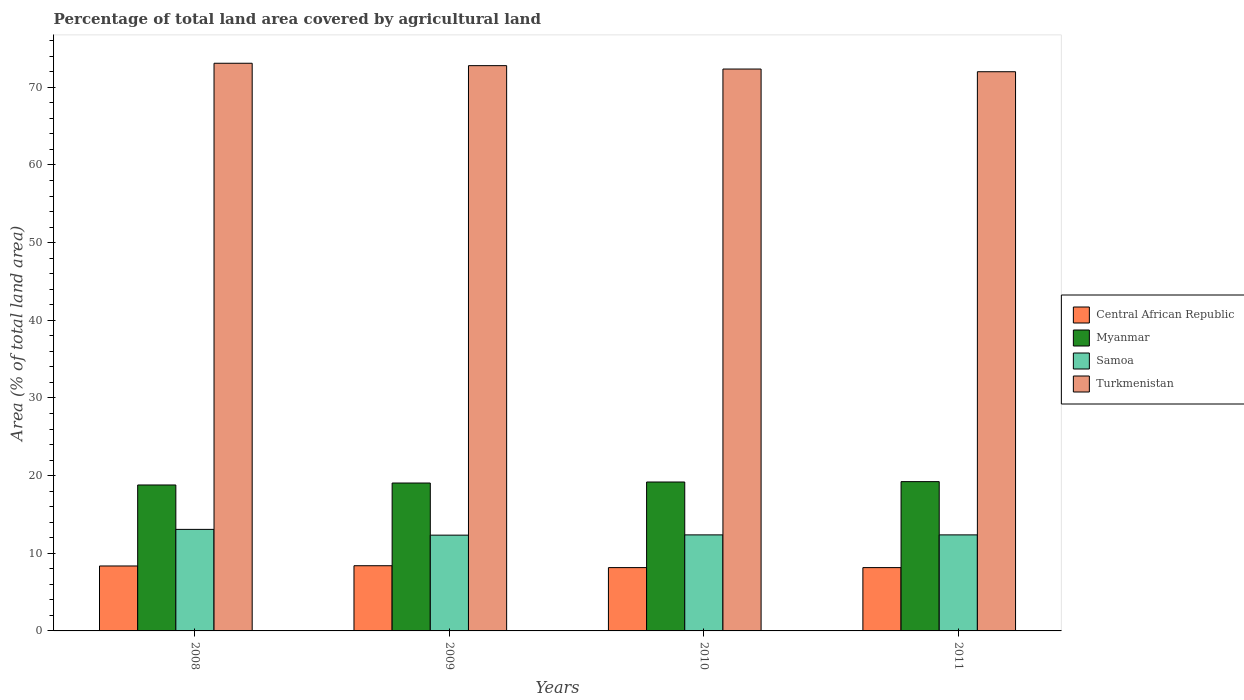How many different coloured bars are there?
Your response must be concise. 4. Are the number of bars per tick equal to the number of legend labels?
Give a very brief answer. Yes. Are the number of bars on each tick of the X-axis equal?
Provide a succinct answer. Yes. How many bars are there on the 4th tick from the left?
Your answer should be very brief. 4. How many bars are there on the 1st tick from the right?
Offer a very short reply. 4. In how many cases, is the number of bars for a given year not equal to the number of legend labels?
Provide a succinct answer. 0. What is the percentage of agricultural land in Central African Republic in 2011?
Ensure brevity in your answer.  8.15. Across all years, what is the maximum percentage of agricultural land in Samoa?
Make the answer very short. 13.07. Across all years, what is the minimum percentage of agricultural land in Samoa?
Your response must be concise. 12.33. In which year was the percentage of agricultural land in Turkmenistan maximum?
Your response must be concise. 2008. In which year was the percentage of agricultural land in Myanmar minimum?
Make the answer very short. 2008. What is the total percentage of agricultural land in Myanmar in the graph?
Make the answer very short. 76.23. What is the difference between the percentage of agricultural land in Turkmenistan in 2011 and the percentage of agricultural land in Myanmar in 2009?
Provide a short and direct response. 52.96. What is the average percentage of agricultural land in Samoa per year?
Offer a terse response. 12.54. In the year 2010, what is the difference between the percentage of agricultural land in Turkmenistan and percentage of agricultural land in Myanmar?
Your answer should be very brief. 53.18. In how many years, is the percentage of agricultural land in Central African Republic greater than 34 %?
Make the answer very short. 0. What is the ratio of the percentage of agricultural land in Turkmenistan in 2009 to that in 2011?
Keep it short and to the point. 1.01. Is the difference between the percentage of agricultural land in Turkmenistan in 2008 and 2009 greater than the difference between the percentage of agricultural land in Myanmar in 2008 and 2009?
Your response must be concise. Yes. What is the difference between the highest and the second highest percentage of agricultural land in Central African Republic?
Your response must be concise. 0.03. What is the difference between the highest and the lowest percentage of agricultural land in Myanmar?
Offer a terse response. 0.43. In how many years, is the percentage of agricultural land in Turkmenistan greater than the average percentage of agricultural land in Turkmenistan taken over all years?
Ensure brevity in your answer.  2. Is the sum of the percentage of agricultural land in Myanmar in 2008 and 2010 greater than the maximum percentage of agricultural land in Turkmenistan across all years?
Make the answer very short. No. What does the 4th bar from the left in 2009 represents?
Offer a terse response. Turkmenistan. What does the 2nd bar from the right in 2009 represents?
Give a very brief answer. Samoa. Is it the case that in every year, the sum of the percentage of agricultural land in Central African Republic and percentage of agricultural land in Samoa is greater than the percentage of agricultural land in Myanmar?
Give a very brief answer. Yes. How many bars are there?
Offer a very short reply. 16. How many years are there in the graph?
Give a very brief answer. 4. Where does the legend appear in the graph?
Your response must be concise. Center right. How many legend labels are there?
Your answer should be compact. 4. What is the title of the graph?
Offer a very short reply. Percentage of total land area covered by agricultural land. What is the label or title of the Y-axis?
Give a very brief answer. Area (% of total land area). What is the Area (% of total land area) in Central African Republic in 2008?
Make the answer very short. 8.36. What is the Area (% of total land area) in Myanmar in 2008?
Keep it short and to the point. 18.79. What is the Area (% of total land area) in Samoa in 2008?
Make the answer very short. 13.07. What is the Area (% of total land area) in Turkmenistan in 2008?
Give a very brief answer. 73.1. What is the Area (% of total land area) of Central African Republic in 2009?
Your answer should be very brief. 8.4. What is the Area (% of total land area) in Myanmar in 2009?
Provide a succinct answer. 19.04. What is the Area (% of total land area) of Samoa in 2009?
Your answer should be very brief. 12.33. What is the Area (% of total land area) of Turkmenistan in 2009?
Your answer should be compact. 72.79. What is the Area (% of total land area) of Central African Republic in 2010?
Your response must be concise. 8.15. What is the Area (% of total land area) of Myanmar in 2010?
Give a very brief answer. 19.17. What is the Area (% of total land area) of Samoa in 2010?
Your answer should be compact. 12.37. What is the Area (% of total land area) of Turkmenistan in 2010?
Your answer should be compact. 72.35. What is the Area (% of total land area) of Central African Republic in 2011?
Make the answer very short. 8.15. What is the Area (% of total land area) of Myanmar in 2011?
Provide a short and direct response. 19.22. What is the Area (% of total land area) of Samoa in 2011?
Your response must be concise. 12.37. What is the Area (% of total land area) of Turkmenistan in 2011?
Your answer should be compact. 72.01. Across all years, what is the maximum Area (% of total land area) of Central African Republic?
Offer a terse response. 8.4. Across all years, what is the maximum Area (% of total land area) of Myanmar?
Your response must be concise. 19.22. Across all years, what is the maximum Area (% of total land area) in Samoa?
Provide a short and direct response. 13.07. Across all years, what is the maximum Area (% of total land area) in Turkmenistan?
Offer a very short reply. 73.1. Across all years, what is the minimum Area (% of total land area) in Central African Republic?
Make the answer very short. 8.15. Across all years, what is the minimum Area (% of total land area) of Myanmar?
Keep it short and to the point. 18.79. Across all years, what is the minimum Area (% of total land area) in Samoa?
Offer a very short reply. 12.33. Across all years, what is the minimum Area (% of total land area) in Turkmenistan?
Provide a succinct answer. 72.01. What is the total Area (% of total land area) of Central African Republic in the graph?
Keep it short and to the point. 33.07. What is the total Area (% of total land area) of Myanmar in the graph?
Ensure brevity in your answer.  76.23. What is the total Area (% of total land area) in Samoa in the graph?
Your answer should be very brief. 50.14. What is the total Area (% of total land area) of Turkmenistan in the graph?
Offer a very short reply. 290.24. What is the difference between the Area (% of total land area) in Central African Republic in 2008 and that in 2009?
Your answer should be compact. -0.03. What is the difference between the Area (% of total land area) of Myanmar in 2008 and that in 2009?
Your response must be concise. -0.25. What is the difference between the Area (% of total land area) of Samoa in 2008 and that in 2009?
Ensure brevity in your answer.  0.74. What is the difference between the Area (% of total land area) in Turkmenistan in 2008 and that in 2009?
Your answer should be very brief. 0.31. What is the difference between the Area (% of total land area) of Central African Republic in 2008 and that in 2010?
Keep it short and to the point. 0.21. What is the difference between the Area (% of total land area) in Myanmar in 2008 and that in 2010?
Offer a very short reply. -0.38. What is the difference between the Area (% of total land area) in Samoa in 2008 and that in 2010?
Offer a terse response. 0.71. What is the difference between the Area (% of total land area) of Turkmenistan in 2008 and that in 2010?
Your response must be concise. 0.74. What is the difference between the Area (% of total land area) of Central African Republic in 2008 and that in 2011?
Your response must be concise. 0.21. What is the difference between the Area (% of total land area) of Myanmar in 2008 and that in 2011?
Provide a short and direct response. -0.43. What is the difference between the Area (% of total land area) of Samoa in 2008 and that in 2011?
Your answer should be very brief. 0.71. What is the difference between the Area (% of total land area) of Turkmenistan in 2008 and that in 2011?
Your response must be concise. 1.09. What is the difference between the Area (% of total land area) in Central African Republic in 2009 and that in 2010?
Keep it short and to the point. 0.24. What is the difference between the Area (% of total land area) in Myanmar in 2009 and that in 2010?
Give a very brief answer. -0.13. What is the difference between the Area (% of total land area) in Samoa in 2009 and that in 2010?
Give a very brief answer. -0.04. What is the difference between the Area (% of total land area) in Turkmenistan in 2009 and that in 2010?
Your response must be concise. 0.44. What is the difference between the Area (% of total land area) of Central African Republic in 2009 and that in 2011?
Ensure brevity in your answer.  0.24. What is the difference between the Area (% of total land area) of Myanmar in 2009 and that in 2011?
Offer a very short reply. -0.18. What is the difference between the Area (% of total land area) of Samoa in 2009 and that in 2011?
Keep it short and to the point. -0.04. What is the difference between the Area (% of total land area) in Turkmenistan in 2009 and that in 2011?
Give a very brief answer. 0.78. What is the difference between the Area (% of total land area) in Central African Republic in 2010 and that in 2011?
Provide a short and direct response. 0. What is the difference between the Area (% of total land area) in Myanmar in 2010 and that in 2011?
Give a very brief answer. -0.05. What is the difference between the Area (% of total land area) of Turkmenistan in 2010 and that in 2011?
Your response must be concise. 0.34. What is the difference between the Area (% of total land area) of Central African Republic in 2008 and the Area (% of total land area) of Myanmar in 2009?
Make the answer very short. -10.68. What is the difference between the Area (% of total land area) of Central African Republic in 2008 and the Area (% of total land area) of Samoa in 2009?
Your response must be concise. -3.97. What is the difference between the Area (% of total land area) of Central African Republic in 2008 and the Area (% of total land area) of Turkmenistan in 2009?
Keep it short and to the point. -64.42. What is the difference between the Area (% of total land area) in Myanmar in 2008 and the Area (% of total land area) in Samoa in 2009?
Keep it short and to the point. 6.46. What is the difference between the Area (% of total land area) of Myanmar in 2008 and the Area (% of total land area) of Turkmenistan in 2009?
Offer a terse response. -54. What is the difference between the Area (% of total land area) of Samoa in 2008 and the Area (% of total land area) of Turkmenistan in 2009?
Provide a short and direct response. -59.71. What is the difference between the Area (% of total land area) of Central African Republic in 2008 and the Area (% of total land area) of Myanmar in 2010?
Offer a terse response. -10.81. What is the difference between the Area (% of total land area) in Central African Republic in 2008 and the Area (% of total land area) in Samoa in 2010?
Your answer should be very brief. -4. What is the difference between the Area (% of total land area) of Central African Republic in 2008 and the Area (% of total land area) of Turkmenistan in 2010?
Make the answer very short. -63.99. What is the difference between the Area (% of total land area) of Myanmar in 2008 and the Area (% of total land area) of Samoa in 2010?
Your answer should be compact. 6.42. What is the difference between the Area (% of total land area) of Myanmar in 2008 and the Area (% of total land area) of Turkmenistan in 2010?
Provide a succinct answer. -53.56. What is the difference between the Area (% of total land area) in Samoa in 2008 and the Area (% of total land area) in Turkmenistan in 2010?
Provide a succinct answer. -59.28. What is the difference between the Area (% of total land area) in Central African Republic in 2008 and the Area (% of total land area) in Myanmar in 2011?
Offer a very short reply. -10.86. What is the difference between the Area (% of total land area) in Central African Republic in 2008 and the Area (% of total land area) in Samoa in 2011?
Provide a short and direct response. -4. What is the difference between the Area (% of total land area) of Central African Republic in 2008 and the Area (% of total land area) of Turkmenistan in 2011?
Offer a very short reply. -63.64. What is the difference between the Area (% of total land area) of Myanmar in 2008 and the Area (% of total land area) of Samoa in 2011?
Give a very brief answer. 6.42. What is the difference between the Area (% of total land area) of Myanmar in 2008 and the Area (% of total land area) of Turkmenistan in 2011?
Make the answer very short. -53.21. What is the difference between the Area (% of total land area) of Samoa in 2008 and the Area (% of total land area) of Turkmenistan in 2011?
Offer a very short reply. -58.93. What is the difference between the Area (% of total land area) of Central African Republic in 2009 and the Area (% of total land area) of Myanmar in 2010?
Provide a succinct answer. -10.78. What is the difference between the Area (% of total land area) in Central African Republic in 2009 and the Area (% of total land area) in Samoa in 2010?
Make the answer very short. -3.97. What is the difference between the Area (% of total land area) in Central African Republic in 2009 and the Area (% of total land area) in Turkmenistan in 2010?
Ensure brevity in your answer.  -63.96. What is the difference between the Area (% of total land area) of Myanmar in 2009 and the Area (% of total land area) of Samoa in 2010?
Your response must be concise. 6.68. What is the difference between the Area (% of total land area) in Myanmar in 2009 and the Area (% of total land area) in Turkmenistan in 2010?
Offer a terse response. -53.31. What is the difference between the Area (% of total land area) of Samoa in 2009 and the Area (% of total land area) of Turkmenistan in 2010?
Make the answer very short. -60.02. What is the difference between the Area (% of total land area) in Central African Republic in 2009 and the Area (% of total land area) in Myanmar in 2011?
Your response must be concise. -10.83. What is the difference between the Area (% of total land area) in Central African Republic in 2009 and the Area (% of total land area) in Samoa in 2011?
Keep it short and to the point. -3.97. What is the difference between the Area (% of total land area) in Central African Republic in 2009 and the Area (% of total land area) in Turkmenistan in 2011?
Make the answer very short. -63.61. What is the difference between the Area (% of total land area) of Myanmar in 2009 and the Area (% of total land area) of Samoa in 2011?
Your answer should be very brief. 6.68. What is the difference between the Area (% of total land area) of Myanmar in 2009 and the Area (% of total land area) of Turkmenistan in 2011?
Provide a succinct answer. -52.96. What is the difference between the Area (% of total land area) of Samoa in 2009 and the Area (% of total land area) of Turkmenistan in 2011?
Keep it short and to the point. -59.67. What is the difference between the Area (% of total land area) in Central African Republic in 2010 and the Area (% of total land area) in Myanmar in 2011?
Make the answer very short. -11.07. What is the difference between the Area (% of total land area) in Central African Republic in 2010 and the Area (% of total land area) in Samoa in 2011?
Keep it short and to the point. -4.21. What is the difference between the Area (% of total land area) in Central African Republic in 2010 and the Area (% of total land area) in Turkmenistan in 2011?
Provide a short and direct response. -63.85. What is the difference between the Area (% of total land area) in Myanmar in 2010 and the Area (% of total land area) in Samoa in 2011?
Provide a succinct answer. 6.81. What is the difference between the Area (% of total land area) in Myanmar in 2010 and the Area (% of total land area) in Turkmenistan in 2011?
Give a very brief answer. -52.83. What is the difference between the Area (% of total land area) in Samoa in 2010 and the Area (% of total land area) in Turkmenistan in 2011?
Provide a short and direct response. -59.64. What is the average Area (% of total land area) in Central African Republic per year?
Your answer should be compact. 8.27. What is the average Area (% of total land area) of Myanmar per year?
Give a very brief answer. 19.06. What is the average Area (% of total land area) of Samoa per year?
Give a very brief answer. 12.54. What is the average Area (% of total land area) in Turkmenistan per year?
Keep it short and to the point. 72.56. In the year 2008, what is the difference between the Area (% of total land area) of Central African Republic and Area (% of total land area) of Myanmar?
Offer a very short reply. -10.43. In the year 2008, what is the difference between the Area (% of total land area) in Central African Republic and Area (% of total land area) in Samoa?
Make the answer very short. -4.71. In the year 2008, what is the difference between the Area (% of total land area) in Central African Republic and Area (% of total land area) in Turkmenistan?
Ensure brevity in your answer.  -64.73. In the year 2008, what is the difference between the Area (% of total land area) of Myanmar and Area (% of total land area) of Samoa?
Offer a very short reply. 5.72. In the year 2008, what is the difference between the Area (% of total land area) in Myanmar and Area (% of total land area) in Turkmenistan?
Ensure brevity in your answer.  -54.3. In the year 2008, what is the difference between the Area (% of total land area) in Samoa and Area (% of total land area) in Turkmenistan?
Offer a terse response. -60.02. In the year 2009, what is the difference between the Area (% of total land area) of Central African Republic and Area (% of total land area) of Myanmar?
Ensure brevity in your answer.  -10.65. In the year 2009, what is the difference between the Area (% of total land area) in Central African Republic and Area (% of total land area) in Samoa?
Your answer should be very brief. -3.94. In the year 2009, what is the difference between the Area (% of total land area) of Central African Republic and Area (% of total land area) of Turkmenistan?
Make the answer very short. -64.39. In the year 2009, what is the difference between the Area (% of total land area) in Myanmar and Area (% of total land area) in Samoa?
Provide a short and direct response. 6.71. In the year 2009, what is the difference between the Area (% of total land area) of Myanmar and Area (% of total land area) of Turkmenistan?
Offer a terse response. -53.74. In the year 2009, what is the difference between the Area (% of total land area) in Samoa and Area (% of total land area) in Turkmenistan?
Your response must be concise. -60.46. In the year 2010, what is the difference between the Area (% of total land area) in Central African Republic and Area (% of total land area) in Myanmar?
Your answer should be very brief. -11.02. In the year 2010, what is the difference between the Area (% of total land area) of Central African Republic and Area (% of total land area) of Samoa?
Your answer should be compact. -4.21. In the year 2010, what is the difference between the Area (% of total land area) in Central African Republic and Area (% of total land area) in Turkmenistan?
Offer a terse response. -64.2. In the year 2010, what is the difference between the Area (% of total land area) of Myanmar and Area (% of total land area) of Samoa?
Your answer should be compact. 6.81. In the year 2010, what is the difference between the Area (% of total land area) in Myanmar and Area (% of total land area) in Turkmenistan?
Your response must be concise. -53.18. In the year 2010, what is the difference between the Area (% of total land area) in Samoa and Area (% of total land area) in Turkmenistan?
Keep it short and to the point. -59.98. In the year 2011, what is the difference between the Area (% of total land area) in Central African Republic and Area (% of total land area) in Myanmar?
Offer a terse response. -11.07. In the year 2011, what is the difference between the Area (% of total land area) of Central African Republic and Area (% of total land area) of Samoa?
Give a very brief answer. -4.21. In the year 2011, what is the difference between the Area (% of total land area) of Central African Republic and Area (% of total land area) of Turkmenistan?
Provide a succinct answer. -63.85. In the year 2011, what is the difference between the Area (% of total land area) in Myanmar and Area (% of total land area) in Samoa?
Offer a very short reply. 6.86. In the year 2011, what is the difference between the Area (% of total land area) of Myanmar and Area (% of total land area) of Turkmenistan?
Provide a short and direct response. -52.78. In the year 2011, what is the difference between the Area (% of total land area) of Samoa and Area (% of total land area) of Turkmenistan?
Your answer should be very brief. -59.64. What is the ratio of the Area (% of total land area) of Myanmar in 2008 to that in 2009?
Your answer should be compact. 0.99. What is the ratio of the Area (% of total land area) in Samoa in 2008 to that in 2009?
Offer a terse response. 1.06. What is the ratio of the Area (% of total land area) of Turkmenistan in 2008 to that in 2009?
Your answer should be very brief. 1. What is the ratio of the Area (% of total land area) in Central African Republic in 2008 to that in 2010?
Provide a succinct answer. 1.03. What is the ratio of the Area (% of total land area) of Myanmar in 2008 to that in 2010?
Provide a short and direct response. 0.98. What is the ratio of the Area (% of total land area) in Samoa in 2008 to that in 2010?
Offer a very short reply. 1.06. What is the ratio of the Area (% of total land area) in Turkmenistan in 2008 to that in 2010?
Your answer should be compact. 1.01. What is the ratio of the Area (% of total land area) of Central African Republic in 2008 to that in 2011?
Make the answer very short. 1.03. What is the ratio of the Area (% of total land area) in Myanmar in 2008 to that in 2011?
Provide a short and direct response. 0.98. What is the ratio of the Area (% of total land area) in Samoa in 2008 to that in 2011?
Your answer should be compact. 1.06. What is the ratio of the Area (% of total land area) in Turkmenistan in 2008 to that in 2011?
Provide a succinct answer. 1.02. What is the ratio of the Area (% of total land area) in Central African Republic in 2009 to that in 2010?
Offer a terse response. 1.03. What is the ratio of the Area (% of total land area) of Samoa in 2009 to that in 2010?
Provide a succinct answer. 1. What is the ratio of the Area (% of total land area) in Central African Republic in 2009 to that in 2011?
Offer a very short reply. 1.03. What is the ratio of the Area (% of total land area) in Myanmar in 2009 to that in 2011?
Keep it short and to the point. 0.99. What is the ratio of the Area (% of total land area) of Turkmenistan in 2009 to that in 2011?
Provide a short and direct response. 1.01. What is the ratio of the Area (% of total land area) in Myanmar in 2010 to that in 2011?
Your response must be concise. 1. What is the ratio of the Area (% of total land area) of Samoa in 2010 to that in 2011?
Provide a short and direct response. 1. What is the ratio of the Area (% of total land area) of Turkmenistan in 2010 to that in 2011?
Keep it short and to the point. 1. What is the difference between the highest and the second highest Area (% of total land area) in Central African Republic?
Your answer should be compact. 0.03. What is the difference between the highest and the second highest Area (% of total land area) of Myanmar?
Your answer should be compact. 0.05. What is the difference between the highest and the second highest Area (% of total land area) of Samoa?
Offer a terse response. 0.71. What is the difference between the highest and the second highest Area (% of total land area) of Turkmenistan?
Keep it short and to the point. 0.31. What is the difference between the highest and the lowest Area (% of total land area) of Central African Republic?
Your response must be concise. 0.24. What is the difference between the highest and the lowest Area (% of total land area) of Myanmar?
Your response must be concise. 0.43. What is the difference between the highest and the lowest Area (% of total land area) of Samoa?
Keep it short and to the point. 0.74. What is the difference between the highest and the lowest Area (% of total land area) in Turkmenistan?
Provide a succinct answer. 1.09. 